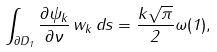Convert formula to latex. <formula><loc_0><loc_0><loc_500><loc_500>\int _ { \partial D _ { 1 } } \frac { \partial \psi _ { k } } { \partial \nu } \, w _ { k } \, d s = \frac { k \sqrt { \pi } } { 2 } \omega ( 1 ) ,</formula> 